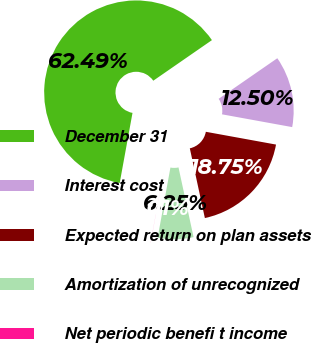Convert chart to OTSL. <chart><loc_0><loc_0><loc_500><loc_500><pie_chart><fcel>December 31<fcel>Interest cost<fcel>Expected return on plan assets<fcel>Amortization of unrecognized<fcel>Net periodic benefi t income<nl><fcel>62.49%<fcel>12.5%<fcel>18.75%<fcel>6.25%<fcel>0.01%<nl></chart> 